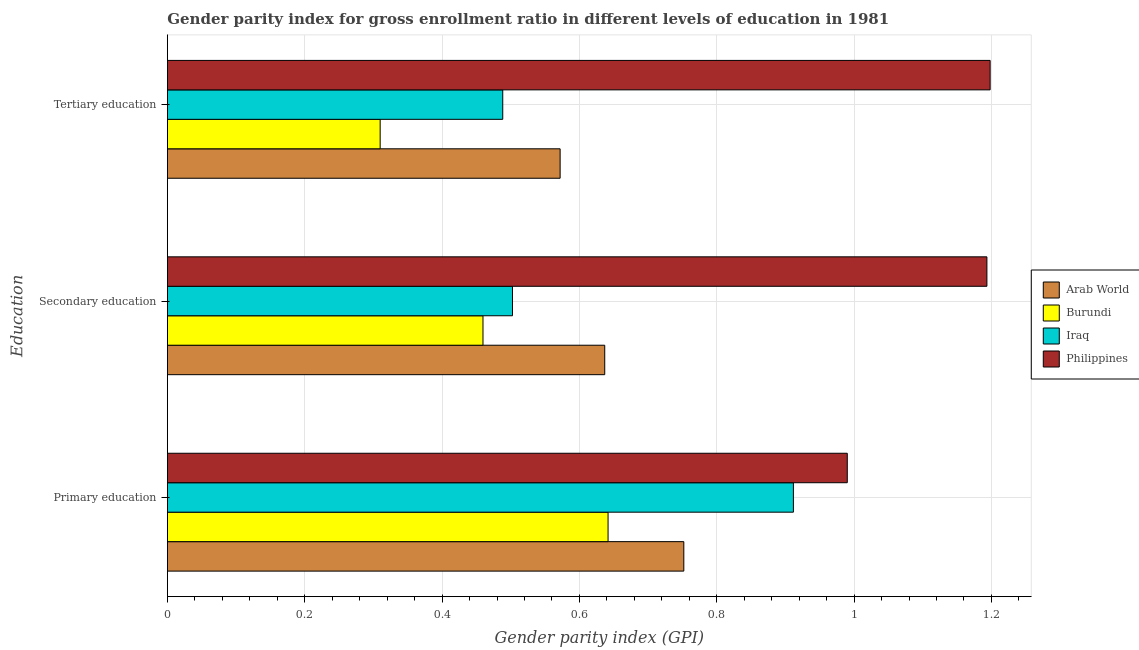How many bars are there on the 3rd tick from the bottom?
Your response must be concise. 4. What is the label of the 2nd group of bars from the top?
Your response must be concise. Secondary education. What is the gender parity index in primary education in Philippines?
Provide a short and direct response. 0.99. Across all countries, what is the maximum gender parity index in tertiary education?
Offer a terse response. 1.2. Across all countries, what is the minimum gender parity index in secondary education?
Give a very brief answer. 0.46. In which country was the gender parity index in secondary education maximum?
Make the answer very short. Philippines. In which country was the gender parity index in secondary education minimum?
Make the answer very short. Burundi. What is the total gender parity index in primary education in the graph?
Keep it short and to the point. 3.3. What is the difference between the gender parity index in primary education in Arab World and that in Iraq?
Offer a terse response. -0.16. What is the difference between the gender parity index in primary education in Arab World and the gender parity index in secondary education in Burundi?
Your response must be concise. 0.29. What is the average gender parity index in primary education per country?
Your response must be concise. 0.82. What is the difference between the gender parity index in secondary education and gender parity index in tertiary education in Arab World?
Ensure brevity in your answer.  0.06. In how many countries, is the gender parity index in tertiary education greater than 0.28 ?
Your answer should be compact. 4. What is the ratio of the gender parity index in primary education in Arab World to that in Burundi?
Your answer should be compact. 1.17. Is the gender parity index in secondary education in Philippines less than that in Burundi?
Provide a short and direct response. No. Is the difference between the gender parity index in primary education in Arab World and Philippines greater than the difference between the gender parity index in tertiary education in Arab World and Philippines?
Offer a very short reply. Yes. What is the difference between the highest and the second highest gender parity index in secondary education?
Make the answer very short. 0.56. What is the difference between the highest and the lowest gender parity index in secondary education?
Keep it short and to the point. 0.73. In how many countries, is the gender parity index in secondary education greater than the average gender parity index in secondary education taken over all countries?
Make the answer very short. 1. Is the sum of the gender parity index in secondary education in Arab World and Iraq greater than the maximum gender parity index in primary education across all countries?
Your answer should be compact. Yes. What does the 4th bar from the top in Primary education represents?
Offer a very short reply. Arab World. What does the 3rd bar from the bottom in Primary education represents?
Give a very brief answer. Iraq. Are all the bars in the graph horizontal?
Your response must be concise. Yes. What is the difference between two consecutive major ticks on the X-axis?
Make the answer very short. 0.2. Are the values on the major ticks of X-axis written in scientific E-notation?
Offer a very short reply. No. Does the graph contain any zero values?
Make the answer very short. No. Does the graph contain grids?
Provide a short and direct response. Yes. How many legend labels are there?
Ensure brevity in your answer.  4. How are the legend labels stacked?
Your answer should be compact. Vertical. What is the title of the graph?
Your response must be concise. Gender parity index for gross enrollment ratio in different levels of education in 1981. Does "Argentina" appear as one of the legend labels in the graph?
Provide a succinct answer. No. What is the label or title of the X-axis?
Offer a very short reply. Gender parity index (GPI). What is the label or title of the Y-axis?
Keep it short and to the point. Education. What is the Gender parity index (GPI) in Arab World in Primary education?
Make the answer very short. 0.75. What is the Gender parity index (GPI) of Burundi in Primary education?
Make the answer very short. 0.64. What is the Gender parity index (GPI) of Iraq in Primary education?
Your answer should be compact. 0.91. What is the Gender parity index (GPI) of Philippines in Primary education?
Your answer should be compact. 0.99. What is the Gender parity index (GPI) of Arab World in Secondary education?
Your response must be concise. 0.64. What is the Gender parity index (GPI) in Burundi in Secondary education?
Keep it short and to the point. 0.46. What is the Gender parity index (GPI) in Iraq in Secondary education?
Provide a succinct answer. 0.5. What is the Gender parity index (GPI) of Philippines in Secondary education?
Give a very brief answer. 1.19. What is the Gender parity index (GPI) of Arab World in Tertiary education?
Provide a succinct answer. 0.57. What is the Gender parity index (GPI) of Burundi in Tertiary education?
Your answer should be compact. 0.31. What is the Gender parity index (GPI) of Iraq in Tertiary education?
Make the answer very short. 0.49. What is the Gender parity index (GPI) in Philippines in Tertiary education?
Your answer should be very brief. 1.2. Across all Education, what is the maximum Gender parity index (GPI) in Arab World?
Your answer should be very brief. 0.75. Across all Education, what is the maximum Gender parity index (GPI) in Burundi?
Provide a succinct answer. 0.64. Across all Education, what is the maximum Gender parity index (GPI) in Iraq?
Ensure brevity in your answer.  0.91. Across all Education, what is the maximum Gender parity index (GPI) of Philippines?
Ensure brevity in your answer.  1.2. Across all Education, what is the minimum Gender parity index (GPI) of Arab World?
Your response must be concise. 0.57. Across all Education, what is the minimum Gender parity index (GPI) of Burundi?
Ensure brevity in your answer.  0.31. Across all Education, what is the minimum Gender parity index (GPI) in Iraq?
Your response must be concise. 0.49. Across all Education, what is the minimum Gender parity index (GPI) in Philippines?
Provide a succinct answer. 0.99. What is the total Gender parity index (GPI) in Arab World in the graph?
Offer a very short reply. 1.96. What is the total Gender parity index (GPI) of Burundi in the graph?
Your response must be concise. 1.41. What is the total Gender parity index (GPI) of Iraq in the graph?
Provide a short and direct response. 1.9. What is the total Gender parity index (GPI) of Philippines in the graph?
Your answer should be compact. 3.38. What is the difference between the Gender parity index (GPI) in Arab World in Primary education and that in Secondary education?
Offer a terse response. 0.12. What is the difference between the Gender parity index (GPI) in Burundi in Primary education and that in Secondary education?
Your response must be concise. 0.18. What is the difference between the Gender parity index (GPI) in Iraq in Primary education and that in Secondary education?
Offer a terse response. 0.41. What is the difference between the Gender parity index (GPI) of Philippines in Primary education and that in Secondary education?
Ensure brevity in your answer.  -0.2. What is the difference between the Gender parity index (GPI) of Arab World in Primary education and that in Tertiary education?
Keep it short and to the point. 0.18. What is the difference between the Gender parity index (GPI) of Burundi in Primary education and that in Tertiary education?
Your answer should be very brief. 0.33. What is the difference between the Gender parity index (GPI) of Iraq in Primary education and that in Tertiary education?
Provide a short and direct response. 0.42. What is the difference between the Gender parity index (GPI) in Philippines in Primary education and that in Tertiary education?
Offer a terse response. -0.21. What is the difference between the Gender parity index (GPI) in Arab World in Secondary education and that in Tertiary education?
Offer a terse response. 0.06. What is the difference between the Gender parity index (GPI) in Burundi in Secondary education and that in Tertiary education?
Your response must be concise. 0.15. What is the difference between the Gender parity index (GPI) in Iraq in Secondary education and that in Tertiary education?
Provide a succinct answer. 0.01. What is the difference between the Gender parity index (GPI) in Philippines in Secondary education and that in Tertiary education?
Provide a succinct answer. -0. What is the difference between the Gender parity index (GPI) in Arab World in Primary education and the Gender parity index (GPI) in Burundi in Secondary education?
Ensure brevity in your answer.  0.29. What is the difference between the Gender parity index (GPI) in Arab World in Primary education and the Gender parity index (GPI) in Iraq in Secondary education?
Give a very brief answer. 0.25. What is the difference between the Gender parity index (GPI) of Arab World in Primary education and the Gender parity index (GPI) of Philippines in Secondary education?
Your answer should be very brief. -0.44. What is the difference between the Gender parity index (GPI) in Burundi in Primary education and the Gender parity index (GPI) in Iraq in Secondary education?
Offer a very short reply. 0.14. What is the difference between the Gender parity index (GPI) in Burundi in Primary education and the Gender parity index (GPI) in Philippines in Secondary education?
Keep it short and to the point. -0.55. What is the difference between the Gender parity index (GPI) of Iraq in Primary education and the Gender parity index (GPI) of Philippines in Secondary education?
Give a very brief answer. -0.28. What is the difference between the Gender parity index (GPI) of Arab World in Primary education and the Gender parity index (GPI) of Burundi in Tertiary education?
Offer a terse response. 0.44. What is the difference between the Gender parity index (GPI) in Arab World in Primary education and the Gender parity index (GPI) in Iraq in Tertiary education?
Provide a short and direct response. 0.26. What is the difference between the Gender parity index (GPI) in Arab World in Primary education and the Gender parity index (GPI) in Philippines in Tertiary education?
Offer a terse response. -0.45. What is the difference between the Gender parity index (GPI) in Burundi in Primary education and the Gender parity index (GPI) in Iraq in Tertiary education?
Ensure brevity in your answer.  0.15. What is the difference between the Gender parity index (GPI) in Burundi in Primary education and the Gender parity index (GPI) in Philippines in Tertiary education?
Offer a very short reply. -0.56. What is the difference between the Gender parity index (GPI) in Iraq in Primary education and the Gender parity index (GPI) in Philippines in Tertiary education?
Offer a very short reply. -0.29. What is the difference between the Gender parity index (GPI) of Arab World in Secondary education and the Gender parity index (GPI) of Burundi in Tertiary education?
Offer a terse response. 0.33. What is the difference between the Gender parity index (GPI) in Arab World in Secondary education and the Gender parity index (GPI) in Iraq in Tertiary education?
Offer a terse response. 0.15. What is the difference between the Gender parity index (GPI) in Arab World in Secondary education and the Gender parity index (GPI) in Philippines in Tertiary education?
Make the answer very short. -0.56. What is the difference between the Gender parity index (GPI) in Burundi in Secondary education and the Gender parity index (GPI) in Iraq in Tertiary education?
Your answer should be compact. -0.03. What is the difference between the Gender parity index (GPI) of Burundi in Secondary education and the Gender parity index (GPI) of Philippines in Tertiary education?
Keep it short and to the point. -0.74. What is the difference between the Gender parity index (GPI) in Iraq in Secondary education and the Gender parity index (GPI) in Philippines in Tertiary education?
Provide a short and direct response. -0.7. What is the average Gender parity index (GPI) in Arab World per Education?
Your answer should be very brief. 0.65. What is the average Gender parity index (GPI) of Burundi per Education?
Give a very brief answer. 0.47. What is the average Gender parity index (GPI) in Iraq per Education?
Your answer should be very brief. 0.63. What is the average Gender parity index (GPI) of Philippines per Education?
Ensure brevity in your answer.  1.13. What is the difference between the Gender parity index (GPI) of Arab World and Gender parity index (GPI) of Burundi in Primary education?
Offer a very short reply. 0.11. What is the difference between the Gender parity index (GPI) in Arab World and Gender parity index (GPI) in Iraq in Primary education?
Provide a short and direct response. -0.16. What is the difference between the Gender parity index (GPI) in Arab World and Gender parity index (GPI) in Philippines in Primary education?
Make the answer very short. -0.24. What is the difference between the Gender parity index (GPI) of Burundi and Gender parity index (GPI) of Iraq in Primary education?
Give a very brief answer. -0.27. What is the difference between the Gender parity index (GPI) in Burundi and Gender parity index (GPI) in Philippines in Primary education?
Give a very brief answer. -0.35. What is the difference between the Gender parity index (GPI) of Iraq and Gender parity index (GPI) of Philippines in Primary education?
Give a very brief answer. -0.08. What is the difference between the Gender parity index (GPI) of Arab World and Gender parity index (GPI) of Burundi in Secondary education?
Offer a terse response. 0.18. What is the difference between the Gender parity index (GPI) of Arab World and Gender parity index (GPI) of Iraq in Secondary education?
Provide a succinct answer. 0.13. What is the difference between the Gender parity index (GPI) of Arab World and Gender parity index (GPI) of Philippines in Secondary education?
Your response must be concise. -0.56. What is the difference between the Gender parity index (GPI) in Burundi and Gender parity index (GPI) in Iraq in Secondary education?
Provide a short and direct response. -0.04. What is the difference between the Gender parity index (GPI) in Burundi and Gender parity index (GPI) in Philippines in Secondary education?
Give a very brief answer. -0.73. What is the difference between the Gender parity index (GPI) in Iraq and Gender parity index (GPI) in Philippines in Secondary education?
Your answer should be very brief. -0.69. What is the difference between the Gender parity index (GPI) in Arab World and Gender parity index (GPI) in Burundi in Tertiary education?
Give a very brief answer. 0.26. What is the difference between the Gender parity index (GPI) in Arab World and Gender parity index (GPI) in Iraq in Tertiary education?
Provide a short and direct response. 0.08. What is the difference between the Gender parity index (GPI) in Arab World and Gender parity index (GPI) in Philippines in Tertiary education?
Your answer should be very brief. -0.63. What is the difference between the Gender parity index (GPI) of Burundi and Gender parity index (GPI) of Iraq in Tertiary education?
Provide a short and direct response. -0.18. What is the difference between the Gender parity index (GPI) of Burundi and Gender parity index (GPI) of Philippines in Tertiary education?
Make the answer very short. -0.89. What is the difference between the Gender parity index (GPI) in Iraq and Gender parity index (GPI) in Philippines in Tertiary education?
Offer a terse response. -0.71. What is the ratio of the Gender parity index (GPI) in Arab World in Primary education to that in Secondary education?
Keep it short and to the point. 1.18. What is the ratio of the Gender parity index (GPI) in Burundi in Primary education to that in Secondary education?
Give a very brief answer. 1.4. What is the ratio of the Gender parity index (GPI) of Iraq in Primary education to that in Secondary education?
Your answer should be compact. 1.81. What is the ratio of the Gender parity index (GPI) of Philippines in Primary education to that in Secondary education?
Ensure brevity in your answer.  0.83. What is the ratio of the Gender parity index (GPI) of Arab World in Primary education to that in Tertiary education?
Provide a short and direct response. 1.31. What is the ratio of the Gender parity index (GPI) of Burundi in Primary education to that in Tertiary education?
Give a very brief answer. 2.07. What is the ratio of the Gender parity index (GPI) in Iraq in Primary education to that in Tertiary education?
Offer a terse response. 1.87. What is the ratio of the Gender parity index (GPI) of Philippines in Primary education to that in Tertiary education?
Your answer should be compact. 0.83. What is the ratio of the Gender parity index (GPI) of Arab World in Secondary education to that in Tertiary education?
Provide a short and direct response. 1.11. What is the ratio of the Gender parity index (GPI) in Burundi in Secondary education to that in Tertiary education?
Your answer should be very brief. 1.48. What is the ratio of the Gender parity index (GPI) of Iraq in Secondary education to that in Tertiary education?
Provide a succinct answer. 1.03. What is the ratio of the Gender parity index (GPI) in Philippines in Secondary education to that in Tertiary education?
Ensure brevity in your answer.  1. What is the difference between the highest and the second highest Gender parity index (GPI) in Arab World?
Your answer should be very brief. 0.12. What is the difference between the highest and the second highest Gender parity index (GPI) in Burundi?
Offer a terse response. 0.18. What is the difference between the highest and the second highest Gender parity index (GPI) in Iraq?
Offer a very short reply. 0.41. What is the difference between the highest and the second highest Gender parity index (GPI) of Philippines?
Provide a short and direct response. 0. What is the difference between the highest and the lowest Gender parity index (GPI) of Arab World?
Provide a short and direct response. 0.18. What is the difference between the highest and the lowest Gender parity index (GPI) of Burundi?
Provide a short and direct response. 0.33. What is the difference between the highest and the lowest Gender parity index (GPI) in Iraq?
Provide a short and direct response. 0.42. What is the difference between the highest and the lowest Gender parity index (GPI) of Philippines?
Your answer should be compact. 0.21. 